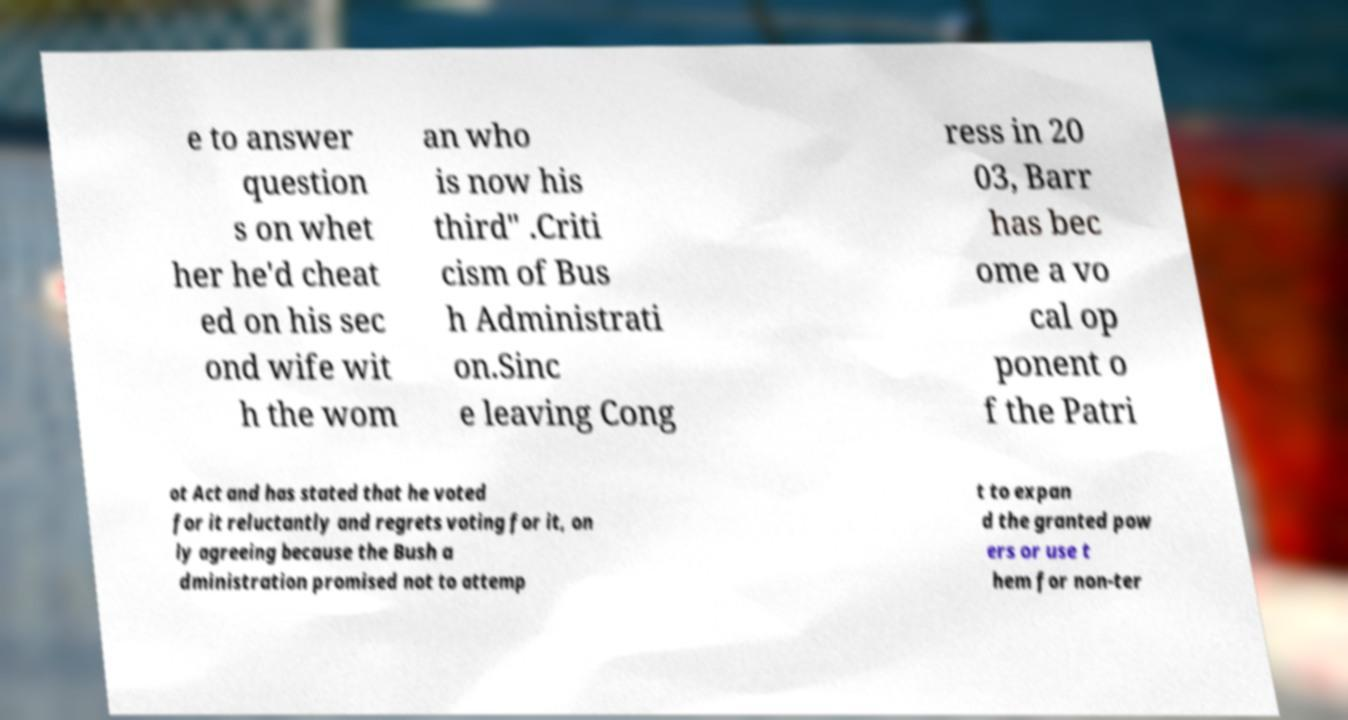Please read and relay the text visible in this image. What does it say? e to answer question s on whet her he'd cheat ed on his sec ond wife wit h the wom an who is now his third" .Criti cism of Bus h Administrati on.Sinc e leaving Cong ress in 20 03, Barr has bec ome a vo cal op ponent o f the Patri ot Act and has stated that he voted for it reluctantly and regrets voting for it, on ly agreeing because the Bush a dministration promised not to attemp t to expan d the granted pow ers or use t hem for non-ter 